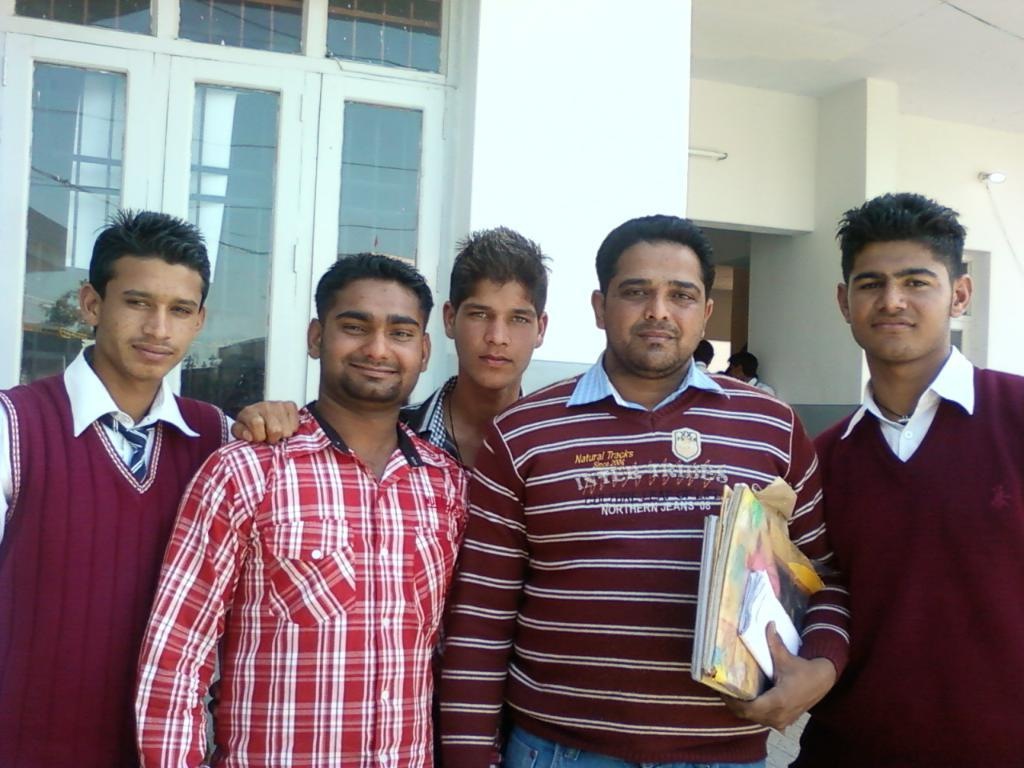How many people are present in the image? There are five men in the image. What is one of the men holding in his hand? One of the men is holding books in his hand. What can be seen in the background of the image? There is a building in the background of the image. Can you describe a specific feature of the building? There is a window in the building. What type of furniture is visible in the image? There is no furniture present in the image; it features five men and a building in the background. What is the mom doing in the image? There is no mom present in the image; it features five men and a building in the background. 